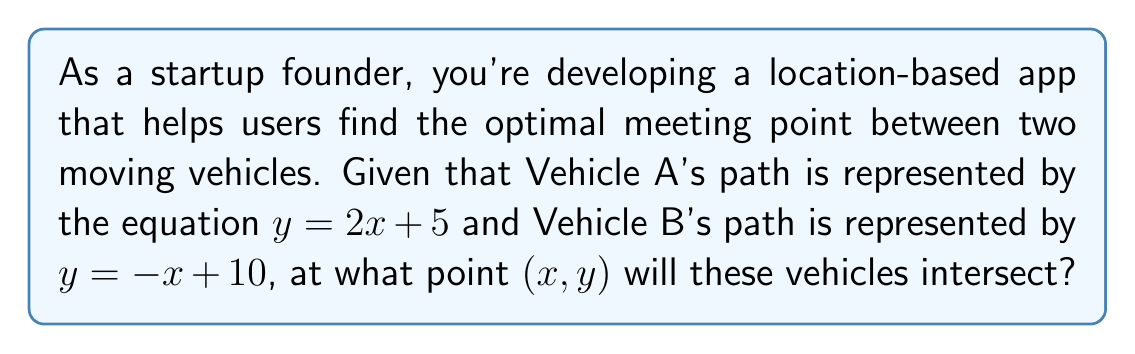Can you solve this math problem? To find the intersection point of two lines, we need to solve their equations simultaneously. Let's approach this step-by-step:

1) We have two equations:
   Line A: $y = 2x + 5$
   Line B: $y = -x + 10$

2) At the intersection point, the x and y coordinates will be the same for both lines. So we can set the right sides of these equations equal to each other:

   $2x + 5 = -x + 10$

3) Now we solve this equation for x:
   $2x + 5 = -x + 10$
   $3x = 5$
   $x = \frac{5}{3}$

4) Now that we know the x-coordinate of the intersection point, we can substitute this value into either of the original equations to find the y-coordinate. Let's use Line A's equation:

   $y = 2x + 5$
   $y = 2(\frac{5}{3}) + 5$
   $y = \frac{10}{3} + 5$
   $y = \frac{10}{3} + \frac{15}{3}$
   $y = \frac{25}{3}$

5) Therefore, the intersection point is $(\frac{5}{3}, \frac{25}{3})$.

[asy]
import geometry;

size(200);

real xmin = -1, xmax = 5, ymin = 0, ymax = 10;
scale(20);

// Draw axes
draw((xmin,0)--(xmax,0),arrow=Arrow(TeXHead));
draw((0,ymin)--(0,ymax),arrow=Arrow(TeXHead));

// Label axes
label("x", (xmax,0), E);
label("y", (0,ymax), N);

// Draw and label lines
draw((0,5)--(3,11), blue, L=Label("y = 2x + 5", position=EndPoint));
draw((0,10)--(5,5), red, L=Label("y = -x + 10", position=EndPoint));

// Mark and label intersection point
dot((5/3, 25/3), purple);
label("(5/3, 25/3)", (5/3, 25/3), NE);

[/asy]
Answer: The vehicles will intersect at the point $(\frac{5}{3}, \frac{25}{3})$, or approximately (1.67, 8.33). 